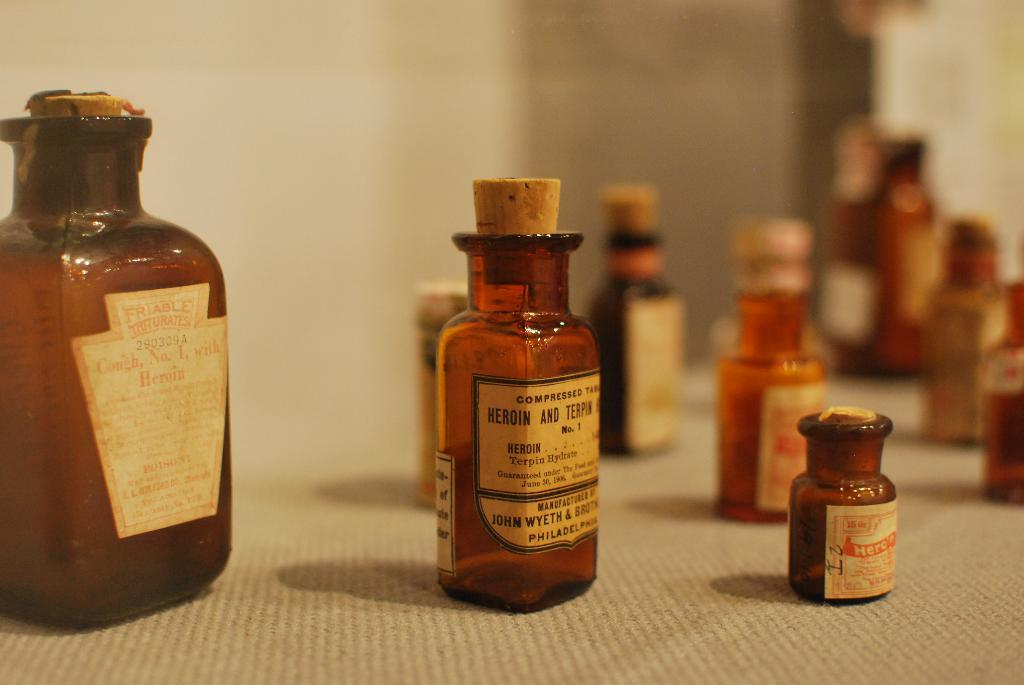<image>
Give a short and clear explanation of the subsequent image. Old style glass medicine bottles are arranged in a display. 